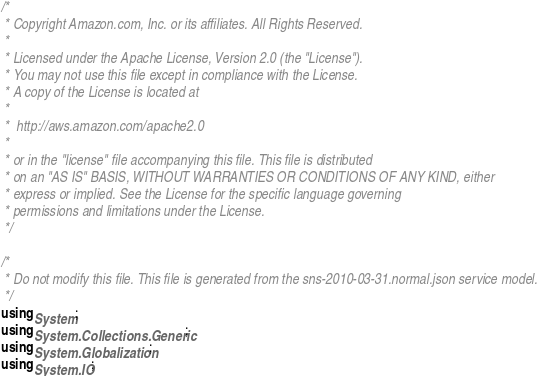Convert code to text. <code><loc_0><loc_0><loc_500><loc_500><_C#_>/*
 * Copyright Amazon.com, Inc. or its affiliates. All Rights Reserved.
 * 
 * Licensed under the Apache License, Version 2.0 (the "License").
 * You may not use this file except in compliance with the License.
 * A copy of the License is located at
 * 
 *  http://aws.amazon.com/apache2.0
 * 
 * or in the "license" file accompanying this file. This file is distributed
 * on an "AS IS" BASIS, WITHOUT WARRANTIES OR CONDITIONS OF ANY KIND, either
 * express or implied. See the License for the specific language governing
 * permissions and limitations under the License.
 */

/*
 * Do not modify this file. This file is generated from the sns-2010-03-31.normal.json service model.
 */
using System;
using System.Collections.Generic;
using System.Globalization;
using System.IO;</code> 